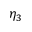<formula> <loc_0><loc_0><loc_500><loc_500>\eta _ { 3 }</formula> 